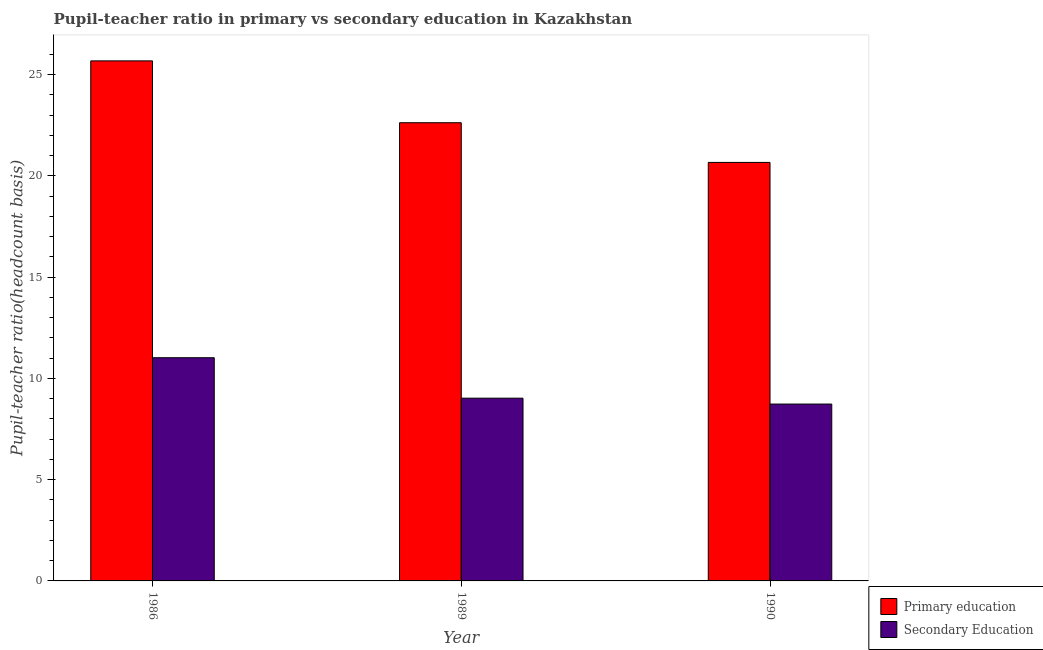How many groups of bars are there?
Offer a terse response. 3. What is the label of the 3rd group of bars from the left?
Your answer should be very brief. 1990. In how many cases, is the number of bars for a given year not equal to the number of legend labels?
Ensure brevity in your answer.  0. What is the pupil-teacher ratio in primary education in 1990?
Provide a succinct answer. 20.66. Across all years, what is the maximum pupil teacher ratio on secondary education?
Your response must be concise. 11.02. Across all years, what is the minimum pupil teacher ratio on secondary education?
Keep it short and to the point. 8.73. In which year was the pupil teacher ratio on secondary education maximum?
Provide a succinct answer. 1986. In which year was the pupil-teacher ratio in primary education minimum?
Ensure brevity in your answer.  1990. What is the total pupil teacher ratio on secondary education in the graph?
Keep it short and to the point. 28.77. What is the difference between the pupil-teacher ratio in primary education in 1986 and that in 1990?
Your answer should be very brief. 5.01. What is the difference between the pupil teacher ratio on secondary education in 1990 and the pupil-teacher ratio in primary education in 1989?
Provide a succinct answer. -0.29. What is the average pupil-teacher ratio in primary education per year?
Keep it short and to the point. 22.99. What is the ratio of the pupil teacher ratio on secondary education in 1986 to that in 1989?
Offer a terse response. 1.22. Is the pupil-teacher ratio in primary education in 1986 less than that in 1989?
Offer a terse response. No. Is the difference between the pupil teacher ratio on secondary education in 1986 and 1990 greater than the difference between the pupil-teacher ratio in primary education in 1986 and 1990?
Offer a very short reply. No. What is the difference between the highest and the second highest pupil-teacher ratio in primary education?
Your response must be concise. 3.05. What is the difference between the highest and the lowest pupil-teacher ratio in primary education?
Your answer should be very brief. 5.01. Is the sum of the pupil teacher ratio on secondary education in 1986 and 1989 greater than the maximum pupil-teacher ratio in primary education across all years?
Provide a succinct answer. Yes. What does the 2nd bar from the left in 1989 represents?
Provide a succinct answer. Secondary Education. What does the 1st bar from the right in 1986 represents?
Provide a short and direct response. Secondary Education. How many bars are there?
Offer a terse response. 6. Are the values on the major ticks of Y-axis written in scientific E-notation?
Your answer should be compact. No. Does the graph contain any zero values?
Provide a short and direct response. No. What is the title of the graph?
Offer a very short reply. Pupil-teacher ratio in primary vs secondary education in Kazakhstan. What is the label or title of the X-axis?
Keep it short and to the point. Year. What is the label or title of the Y-axis?
Offer a terse response. Pupil-teacher ratio(headcount basis). What is the Pupil-teacher ratio(headcount basis) in Primary education in 1986?
Give a very brief answer. 25.68. What is the Pupil-teacher ratio(headcount basis) in Secondary Education in 1986?
Your answer should be compact. 11.02. What is the Pupil-teacher ratio(headcount basis) in Primary education in 1989?
Give a very brief answer. 22.62. What is the Pupil-teacher ratio(headcount basis) of Secondary Education in 1989?
Your answer should be very brief. 9.02. What is the Pupil-teacher ratio(headcount basis) of Primary education in 1990?
Your response must be concise. 20.66. What is the Pupil-teacher ratio(headcount basis) of Secondary Education in 1990?
Provide a succinct answer. 8.73. Across all years, what is the maximum Pupil-teacher ratio(headcount basis) of Primary education?
Make the answer very short. 25.68. Across all years, what is the maximum Pupil-teacher ratio(headcount basis) in Secondary Education?
Offer a very short reply. 11.02. Across all years, what is the minimum Pupil-teacher ratio(headcount basis) in Primary education?
Provide a short and direct response. 20.66. Across all years, what is the minimum Pupil-teacher ratio(headcount basis) of Secondary Education?
Your answer should be compact. 8.73. What is the total Pupil-teacher ratio(headcount basis) of Primary education in the graph?
Offer a terse response. 68.96. What is the total Pupil-teacher ratio(headcount basis) of Secondary Education in the graph?
Your answer should be compact. 28.77. What is the difference between the Pupil-teacher ratio(headcount basis) of Primary education in 1986 and that in 1989?
Your answer should be very brief. 3.05. What is the difference between the Pupil-teacher ratio(headcount basis) in Secondary Education in 1986 and that in 1989?
Make the answer very short. 2. What is the difference between the Pupil-teacher ratio(headcount basis) in Primary education in 1986 and that in 1990?
Your answer should be very brief. 5.01. What is the difference between the Pupil-teacher ratio(headcount basis) of Secondary Education in 1986 and that in 1990?
Make the answer very short. 2.29. What is the difference between the Pupil-teacher ratio(headcount basis) in Primary education in 1989 and that in 1990?
Provide a succinct answer. 1.96. What is the difference between the Pupil-teacher ratio(headcount basis) in Secondary Education in 1989 and that in 1990?
Offer a terse response. 0.29. What is the difference between the Pupil-teacher ratio(headcount basis) of Primary education in 1986 and the Pupil-teacher ratio(headcount basis) of Secondary Education in 1989?
Give a very brief answer. 16.65. What is the difference between the Pupil-teacher ratio(headcount basis) in Primary education in 1986 and the Pupil-teacher ratio(headcount basis) in Secondary Education in 1990?
Make the answer very short. 16.94. What is the difference between the Pupil-teacher ratio(headcount basis) in Primary education in 1989 and the Pupil-teacher ratio(headcount basis) in Secondary Education in 1990?
Your answer should be very brief. 13.89. What is the average Pupil-teacher ratio(headcount basis) in Primary education per year?
Provide a short and direct response. 22.99. What is the average Pupil-teacher ratio(headcount basis) in Secondary Education per year?
Make the answer very short. 9.59. In the year 1986, what is the difference between the Pupil-teacher ratio(headcount basis) of Primary education and Pupil-teacher ratio(headcount basis) of Secondary Education?
Your response must be concise. 14.66. In the year 1989, what is the difference between the Pupil-teacher ratio(headcount basis) in Primary education and Pupil-teacher ratio(headcount basis) in Secondary Education?
Your response must be concise. 13.6. In the year 1990, what is the difference between the Pupil-teacher ratio(headcount basis) in Primary education and Pupil-teacher ratio(headcount basis) in Secondary Education?
Keep it short and to the point. 11.93. What is the ratio of the Pupil-teacher ratio(headcount basis) in Primary education in 1986 to that in 1989?
Ensure brevity in your answer.  1.14. What is the ratio of the Pupil-teacher ratio(headcount basis) in Secondary Education in 1986 to that in 1989?
Your answer should be very brief. 1.22. What is the ratio of the Pupil-teacher ratio(headcount basis) of Primary education in 1986 to that in 1990?
Ensure brevity in your answer.  1.24. What is the ratio of the Pupil-teacher ratio(headcount basis) of Secondary Education in 1986 to that in 1990?
Your answer should be compact. 1.26. What is the ratio of the Pupil-teacher ratio(headcount basis) of Primary education in 1989 to that in 1990?
Provide a short and direct response. 1.09. What is the ratio of the Pupil-teacher ratio(headcount basis) in Secondary Education in 1989 to that in 1990?
Keep it short and to the point. 1.03. What is the difference between the highest and the second highest Pupil-teacher ratio(headcount basis) in Primary education?
Keep it short and to the point. 3.05. What is the difference between the highest and the second highest Pupil-teacher ratio(headcount basis) of Secondary Education?
Offer a terse response. 2. What is the difference between the highest and the lowest Pupil-teacher ratio(headcount basis) in Primary education?
Provide a succinct answer. 5.01. What is the difference between the highest and the lowest Pupil-teacher ratio(headcount basis) of Secondary Education?
Keep it short and to the point. 2.29. 